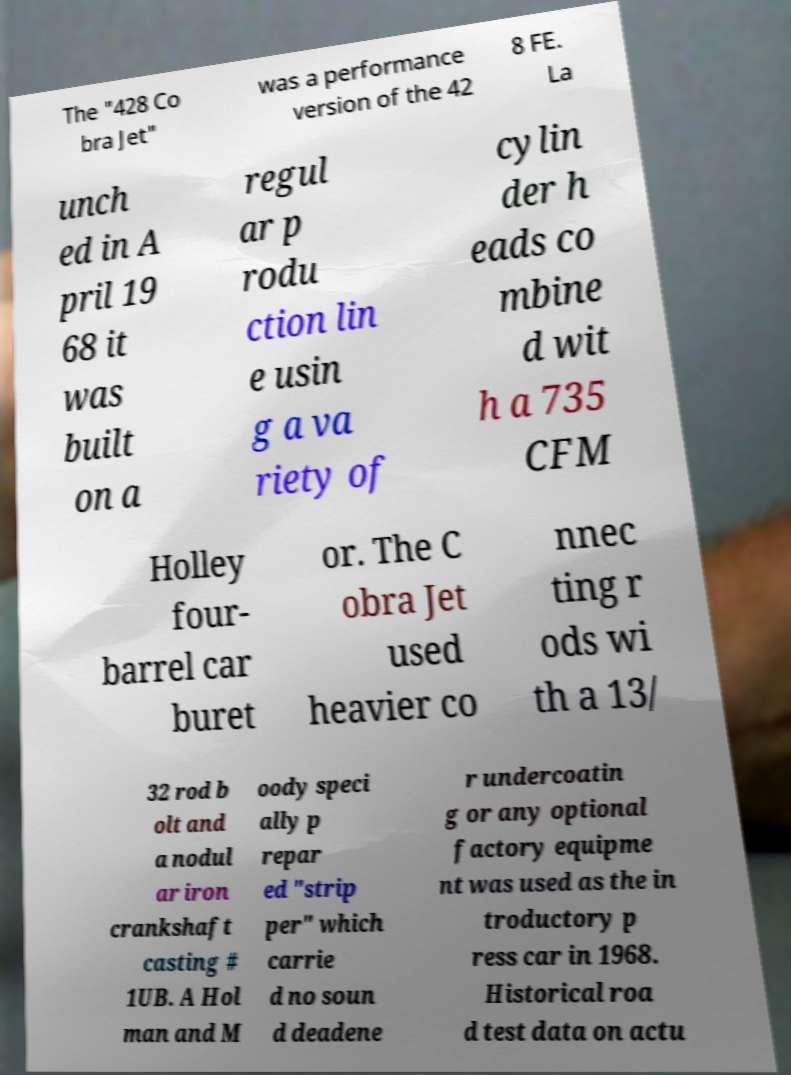I need the written content from this picture converted into text. Can you do that? The "428 Co bra Jet" was a performance version of the 42 8 FE. La unch ed in A pril 19 68 it was built on a regul ar p rodu ction lin e usin g a va riety of cylin der h eads co mbine d wit h a 735 CFM Holley four- barrel car buret or. The C obra Jet used heavier co nnec ting r ods wi th a 13/ 32 rod b olt and a nodul ar iron crankshaft casting # 1UB. A Hol man and M oody speci ally p repar ed "strip per" which carrie d no soun d deadene r undercoatin g or any optional factory equipme nt was used as the in troductory p ress car in 1968. Historical roa d test data on actu 